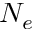<formula> <loc_0><loc_0><loc_500><loc_500>N _ { e }</formula> 